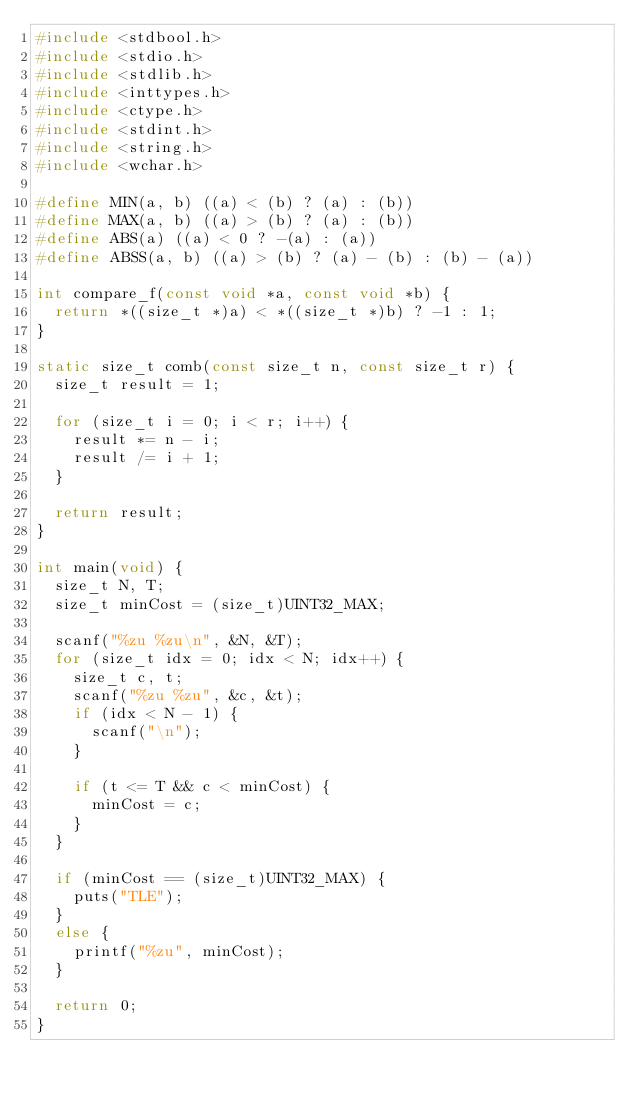<code> <loc_0><loc_0><loc_500><loc_500><_C_>#include <stdbool.h>
#include <stdio.h>
#include <stdlib.h>
#include <inttypes.h>
#include <ctype.h>
#include <stdint.h>
#include <string.h>
#include <wchar.h>

#define MIN(a, b) ((a) < (b) ? (a) : (b))
#define MAX(a, b) ((a) > (b) ? (a) : (b))
#define ABS(a) ((a) < 0 ? -(a) : (a))
#define ABSS(a, b) ((a) > (b) ? (a) - (b) : (b) - (a))

int compare_f(const void *a, const void *b) {
	return *((size_t *)a) < *((size_t *)b) ? -1 : 1;
}

static size_t comb(const size_t n, const size_t r) {
	size_t result = 1;

	for (size_t i = 0; i < r; i++) {
		result *= n - i;
		result /= i + 1;
	}

	return result;
}

int main(void) {
	size_t N, T;
	size_t minCost = (size_t)UINT32_MAX;

	scanf("%zu %zu\n", &N, &T);
	for (size_t idx = 0; idx < N; idx++) {
		size_t c, t;
		scanf("%zu %zu", &c, &t);
		if (idx < N - 1) {
			scanf("\n");
		}

		if (t <= T && c < minCost) {
			minCost = c;
		}
	}

	if (minCost == (size_t)UINT32_MAX) {
		puts("TLE");
	}
	else {
		printf("%zu", minCost);
	}

	return 0;
}
</code> 